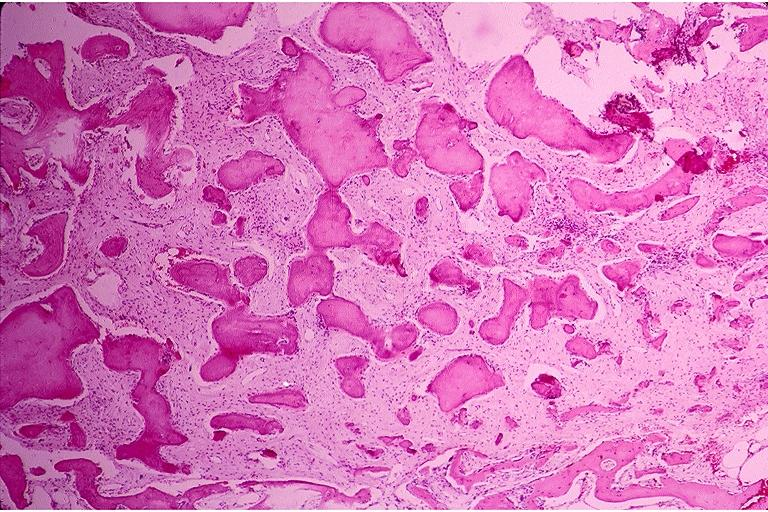does history show benign fibro-osseous lesion?
Answer the question using a single word or phrase. No 